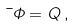Convert formula to latex. <formula><loc_0><loc_0><loc_500><loc_500>\mu \Phi = Q \, ,</formula> 